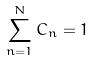Convert formula to latex. <formula><loc_0><loc_0><loc_500><loc_500>\sum _ { n = 1 } ^ { N } C _ { n } = 1</formula> 